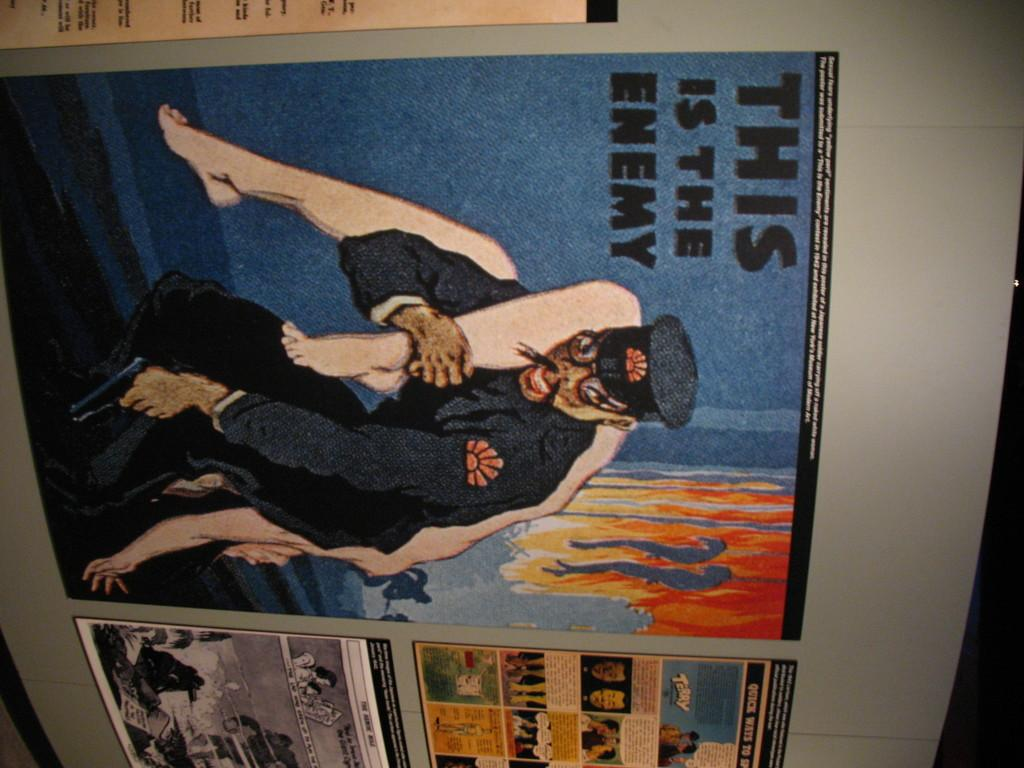<image>
Provide a brief description of the given image. A picture of a man states "this is the enemy.". 